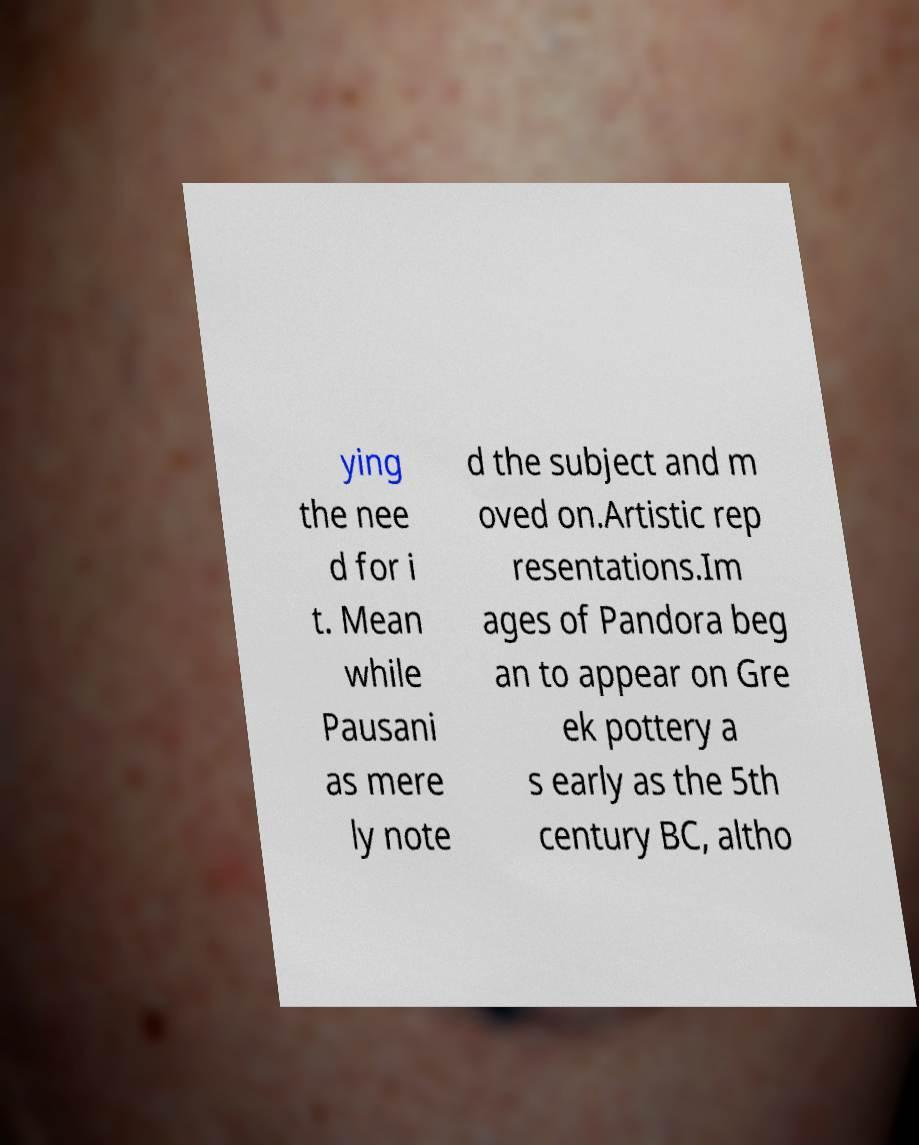I need the written content from this picture converted into text. Can you do that? ying the nee d for i t. Mean while Pausani as mere ly note d the subject and m oved on.Artistic rep resentations.Im ages of Pandora beg an to appear on Gre ek pottery a s early as the 5th century BC, altho 